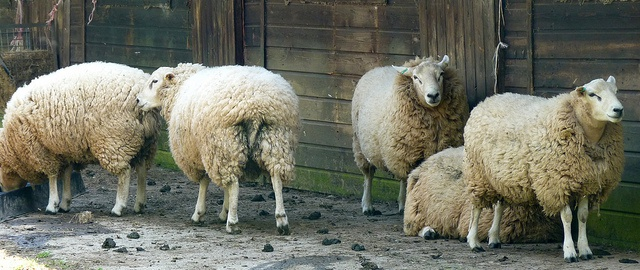Describe the objects in this image and their specific colors. I can see sheep in black, tan, darkgreen, darkgray, and beige tones, sheep in black, ivory, darkgray, tan, and gray tones, sheep in black, ivory, tan, gray, and olive tones, sheep in black, darkgray, gray, and darkgreen tones, and sheep in black, darkgray, and gray tones in this image. 